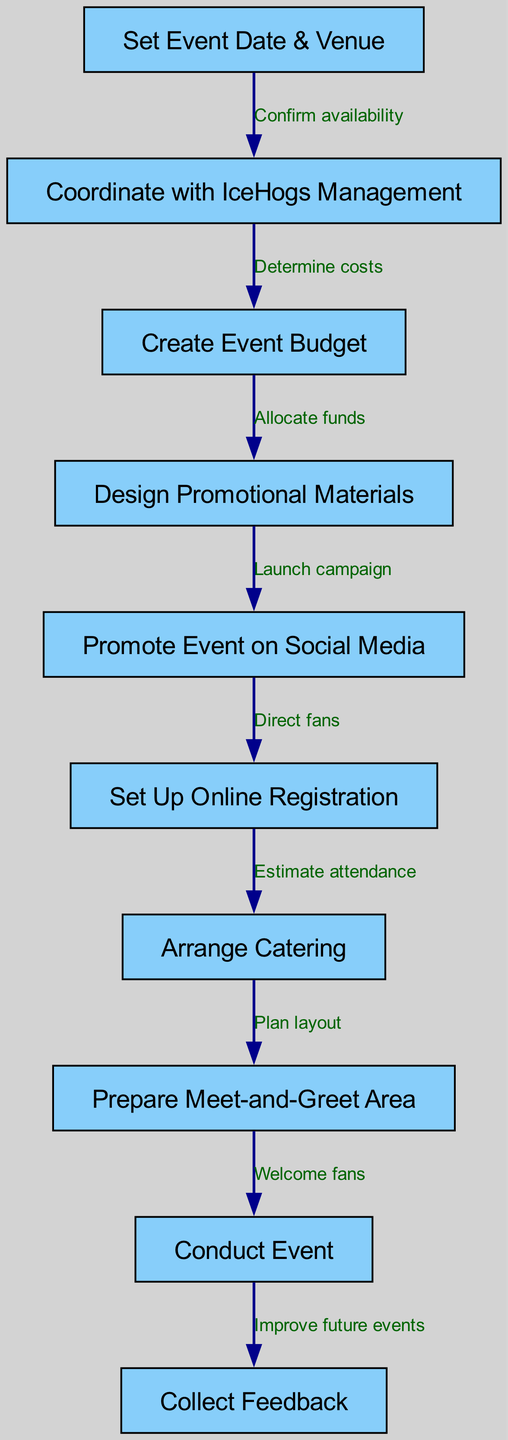What is the first step in the diagram? The first node in the diagram is labeled "Set Event Date & Venue," which indicates it is the initial point of the process flow for organizing the fan meet-up event.
Answer: Set Event Date & Venue How many nodes are in the diagram? By counting all the unique nodes listed in the data, there are ten distinct steps that pertain to organizing and executing the event.
Answer: 10 What relationship exists between "Coordinate with IceHogs Management" and "Create Event Budget"? The relationship between these two nodes is represented by an edge that indicates "Determine costs," which suggests that after coordinating with IceHogs management, understanding costs is necessary for budget creation.
Answer: Determine costs What is the last step in the process flow? The last node in the diagram is labeled "Collect Feedback," which represents the concluding action after conducting the event to help improve future events.
Answer: Collect Feedback Which step directly leads to the arrangement of catering? The step "Set Up Online Registration" directly leads to "Arrange Catering," as captured in the diagram's flow which connects these two actions.
Answer: Set Up Online Registration What promotional action follows after designing promotional materials? Once promotional materials are designed, the next step in the process is to "Promote Event on Social Media," which is indicated by the direct flow from one node to the other.
Answer: Promote Event on Social Media What is the purpose of collecting feedback? The purpose of collecting feedback is to "Improve future events," which is specified as an outcome of conducting the event according to the flow diagram.
Answer: Improve future events Which two steps are connected with the label "Launch campaign"? The steps connected with the label "Launch campaign" are "Design Promotional Materials" and "Promote Event on Social Media," indicating a flow from preparation to promotion.
Answer: Design Promotional Materials, Promote Event on Social Media What step involves estimating attendance? The node labeled "Set Up Online Registration" is responsible for estimating attendance, as indicated by the edge that connects to the "Arrange Catering" step.
Answer: Set Up Online Registration 